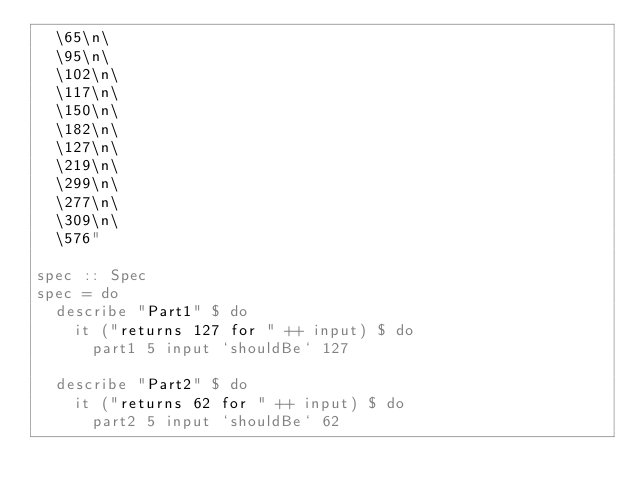<code> <loc_0><loc_0><loc_500><loc_500><_Haskell_>  \65\n\
  \95\n\
  \102\n\
  \117\n\
  \150\n\
  \182\n\
  \127\n\
  \219\n\
  \299\n\
  \277\n\
  \309\n\
  \576"

spec :: Spec
spec = do
  describe "Part1" $ do
    it ("returns 127 for " ++ input) $ do
      part1 5 input `shouldBe` 127

  describe "Part2" $ do
    it ("returns 62 for " ++ input) $ do
      part2 5 input `shouldBe` 62
</code> 